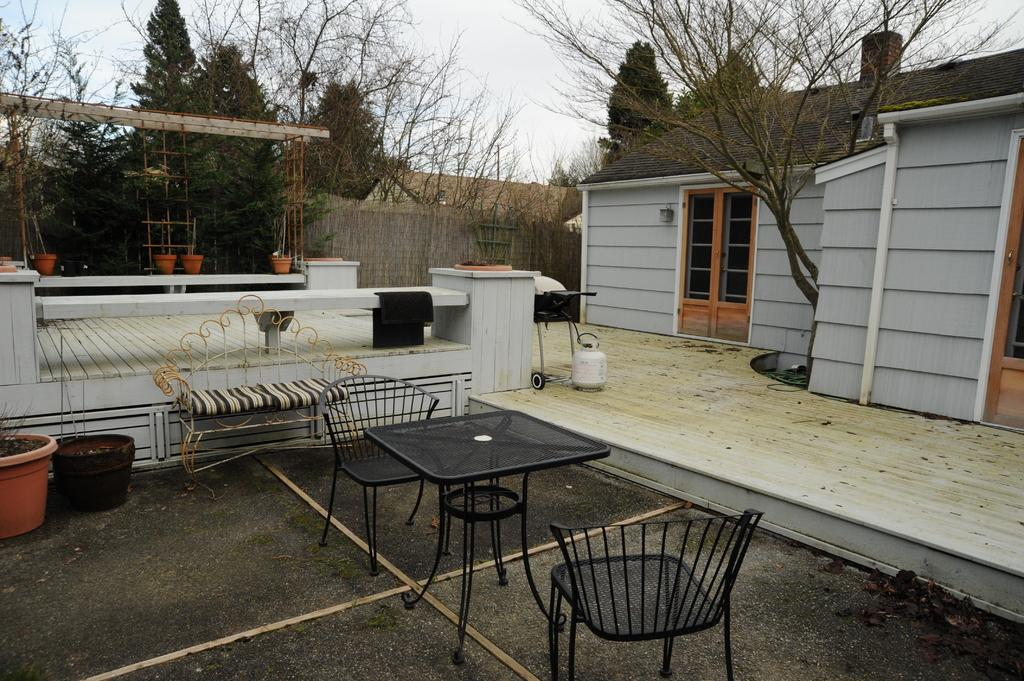What type of structure is present in the image? There is a building in the image. What type of vegetation can be seen in the image? There are trees in the image. What type of furniture is visible in the image? There are chairs, a table, and a couch in the image. What type of decorative items are present in the image? There are flower pots in the image. What else can be seen in the image besides the mentioned objects? There are other objects in the image. What is visible in the background of the image? The sky is visible in the background of the image. How many bikes are parked in the bedroom in the image? There is no bedroom or bikes present in the image. What angle is the building leaning at in the image? The building is not leaning in the image; it is standing upright. 